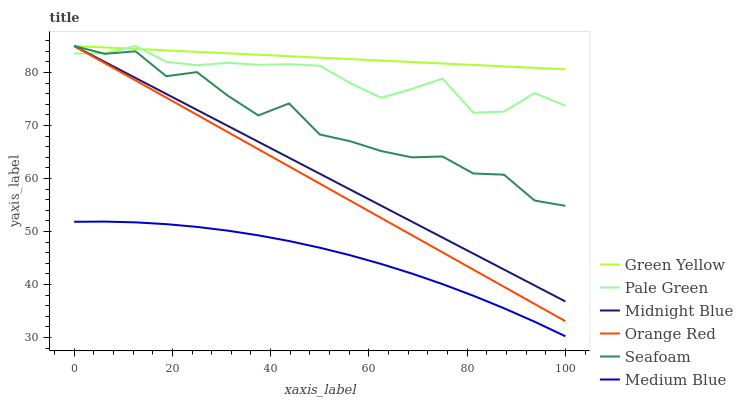Does Medium Blue have the minimum area under the curve?
Answer yes or no. Yes. Does Green Yellow have the maximum area under the curve?
Answer yes or no. Yes. Does Seafoam have the minimum area under the curve?
Answer yes or no. No. Does Seafoam have the maximum area under the curve?
Answer yes or no. No. Is Midnight Blue the smoothest?
Answer yes or no. Yes. Is Seafoam the roughest?
Answer yes or no. Yes. Is Medium Blue the smoothest?
Answer yes or no. No. Is Medium Blue the roughest?
Answer yes or no. No. Does Medium Blue have the lowest value?
Answer yes or no. Yes. Does Seafoam have the lowest value?
Answer yes or no. No. Does Orange Red have the highest value?
Answer yes or no. Yes. Does Medium Blue have the highest value?
Answer yes or no. No. Is Medium Blue less than Orange Red?
Answer yes or no. Yes. Is Orange Red greater than Medium Blue?
Answer yes or no. Yes. Does Seafoam intersect Green Yellow?
Answer yes or no. Yes. Is Seafoam less than Green Yellow?
Answer yes or no. No. Is Seafoam greater than Green Yellow?
Answer yes or no. No. Does Medium Blue intersect Orange Red?
Answer yes or no. No. 